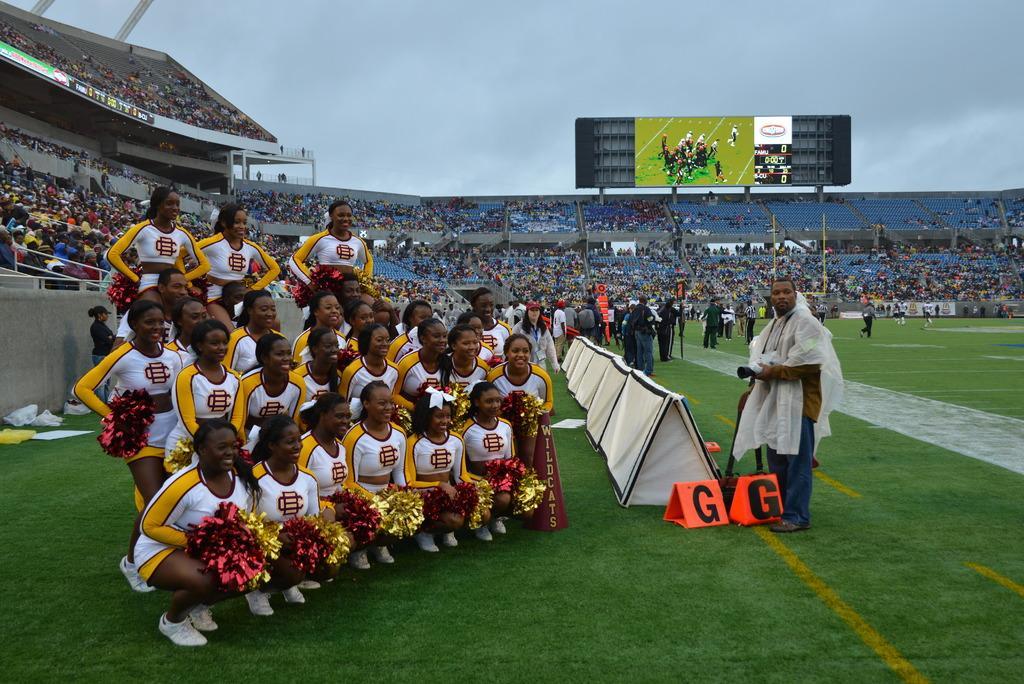Can you describe this image briefly? In the picture I can see a group of people among them some are standing and some are in squad positions. In the background I can see the sky, the grass, a screen, fence and some other objects on the ground. This is a inside view of a stadium. In the background I can see the sky. 